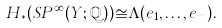Convert formula to latex. <formula><loc_0><loc_0><loc_500><loc_500>H _ { \ast } ( S P ^ { \infty } ( Y ; \mathbb { Q } ) ) \cong \Lambda ( e _ { 1 } , \dots , e _ { m } ) .</formula> 